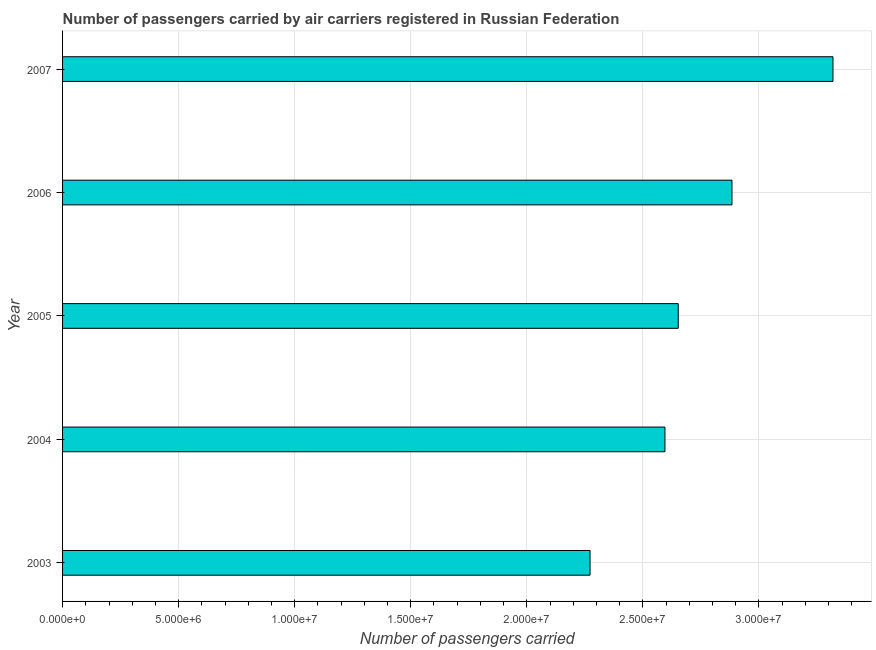Does the graph contain grids?
Give a very brief answer. Yes. What is the title of the graph?
Make the answer very short. Number of passengers carried by air carriers registered in Russian Federation. What is the label or title of the X-axis?
Offer a terse response. Number of passengers carried. What is the label or title of the Y-axis?
Offer a very short reply. Year. What is the number of passengers carried in 2006?
Provide a succinct answer. 2.88e+07. Across all years, what is the maximum number of passengers carried?
Your answer should be compact. 3.32e+07. Across all years, what is the minimum number of passengers carried?
Provide a short and direct response. 2.27e+07. In which year was the number of passengers carried maximum?
Your response must be concise. 2007. In which year was the number of passengers carried minimum?
Offer a very short reply. 2003. What is the sum of the number of passengers carried?
Offer a terse response. 1.37e+08. What is the difference between the number of passengers carried in 2003 and 2006?
Provide a short and direct response. -6.11e+06. What is the average number of passengers carried per year?
Offer a terse response. 2.74e+07. What is the median number of passengers carried?
Give a very brief answer. 2.65e+07. In how many years, is the number of passengers carried greater than 17000000 ?
Your response must be concise. 5. Do a majority of the years between 2006 and 2004 (inclusive) have number of passengers carried greater than 19000000 ?
Ensure brevity in your answer.  Yes. Is the number of passengers carried in 2004 less than that in 2006?
Your answer should be very brief. Yes. What is the difference between the highest and the second highest number of passengers carried?
Keep it short and to the point. 4.35e+06. What is the difference between the highest and the lowest number of passengers carried?
Provide a short and direct response. 1.05e+07. In how many years, is the number of passengers carried greater than the average number of passengers carried taken over all years?
Provide a short and direct response. 2. How many bars are there?
Ensure brevity in your answer.  5. Are all the bars in the graph horizontal?
Offer a terse response. Yes. What is the difference between two consecutive major ticks on the X-axis?
Keep it short and to the point. 5.00e+06. What is the Number of passengers carried in 2003?
Keep it short and to the point. 2.27e+07. What is the Number of passengers carried of 2004?
Make the answer very short. 2.59e+07. What is the Number of passengers carried of 2005?
Offer a terse response. 2.65e+07. What is the Number of passengers carried of 2006?
Provide a short and direct response. 2.88e+07. What is the Number of passengers carried in 2007?
Provide a succinct answer. 3.32e+07. What is the difference between the Number of passengers carried in 2003 and 2004?
Provide a short and direct response. -3.23e+06. What is the difference between the Number of passengers carried in 2003 and 2005?
Ensure brevity in your answer.  -3.80e+06. What is the difference between the Number of passengers carried in 2003 and 2006?
Give a very brief answer. -6.11e+06. What is the difference between the Number of passengers carried in 2003 and 2007?
Give a very brief answer. -1.05e+07. What is the difference between the Number of passengers carried in 2004 and 2005?
Your response must be concise. -5.73e+05. What is the difference between the Number of passengers carried in 2004 and 2006?
Offer a terse response. -2.89e+06. What is the difference between the Number of passengers carried in 2004 and 2007?
Offer a very short reply. -7.24e+06. What is the difference between the Number of passengers carried in 2005 and 2006?
Ensure brevity in your answer.  -2.31e+06. What is the difference between the Number of passengers carried in 2005 and 2007?
Your response must be concise. -6.67e+06. What is the difference between the Number of passengers carried in 2006 and 2007?
Ensure brevity in your answer.  -4.35e+06. What is the ratio of the Number of passengers carried in 2003 to that in 2004?
Offer a terse response. 0.88. What is the ratio of the Number of passengers carried in 2003 to that in 2005?
Keep it short and to the point. 0.86. What is the ratio of the Number of passengers carried in 2003 to that in 2006?
Offer a very short reply. 0.79. What is the ratio of the Number of passengers carried in 2003 to that in 2007?
Provide a succinct answer. 0.69. What is the ratio of the Number of passengers carried in 2004 to that in 2006?
Provide a short and direct response. 0.9. What is the ratio of the Number of passengers carried in 2004 to that in 2007?
Provide a succinct answer. 0.78. What is the ratio of the Number of passengers carried in 2005 to that in 2007?
Give a very brief answer. 0.8. What is the ratio of the Number of passengers carried in 2006 to that in 2007?
Keep it short and to the point. 0.87. 